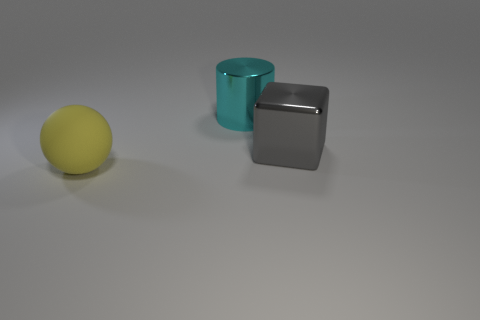How many objects are either objects that are right of the big yellow matte thing or big things on the left side of the block?
Give a very brief answer. 3. Is the number of big cyan metal cylinders that are left of the ball less than the number of big green spheres?
Give a very brief answer. No. Is the big gray block made of the same material as the large thing that is behind the cube?
Provide a succinct answer. Yes. What is the big yellow thing made of?
Your answer should be compact. Rubber. What material is the thing in front of the shiny thing in front of the metal thing that is behind the large gray metallic block?
Your answer should be very brief. Rubber. Are there any other things that are the same shape as the cyan thing?
Your response must be concise. No. What color is the shiny object behind the big metal object that is on the right side of the large metallic cylinder?
Provide a short and direct response. Cyan. How many big blue shiny balls are there?
Your answer should be compact. 0. What number of shiny objects are either big yellow objects or tiny spheres?
Offer a terse response. 0. What is the material of the large object that is in front of the large shiny thing that is to the right of the big cyan cylinder?
Your answer should be very brief. Rubber. 